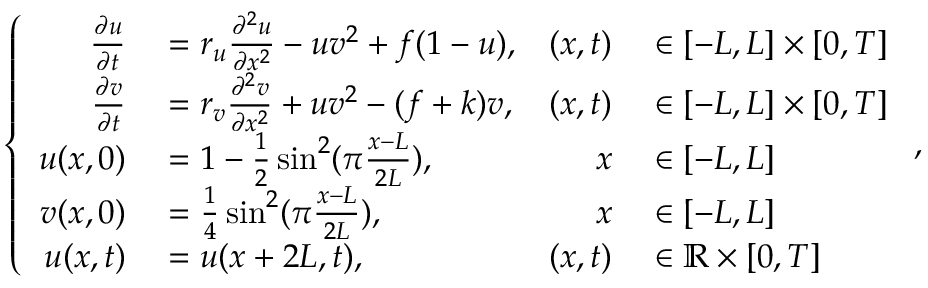Convert formula to latex. <formula><loc_0><loc_0><loc_500><loc_500>\left \{ \begin{array} { r l r l } { \frac { \partial u } { \partial t } } & = r _ { u } \frac { \partial ^ { 2 } u } { \partial x ^ { 2 } } - u v ^ { 2 } + f ( 1 - u ) , } & { ( x , t ) } & \in [ - L , L ] \times [ 0 , T ] } \\ { \frac { \partial v } { \partial t } } & = r _ { v } \frac { \partial ^ { 2 } v } { \partial x ^ { 2 } } + u v ^ { 2 } - ( f + k ) v , } & { ( x , t ) } & \in [ - L , L ] \times [ 0 , T ] } \\ { u ( x , 0 ) } & = 1 - \frac { 1 } { 2 } \sin ^ { 2 } ( \pi \frac { x - L } { 2 L } ) , } & { x } & \in [ - L , L ] } \\ { v ( x , 0 ) } & = \frac { 1 } { 4 } \sin ^ { 2 } ( \pi \frac { x - L } { 2 L } ) , } & { x } & \in [ - L , L ] } \\ { u ( x , t ) } & = u ( x + 2 L , t ) , } & { ( x , t ) } & \in \mathbb { R } \times [ 0 , T ] } \end{array} ,</formula> 